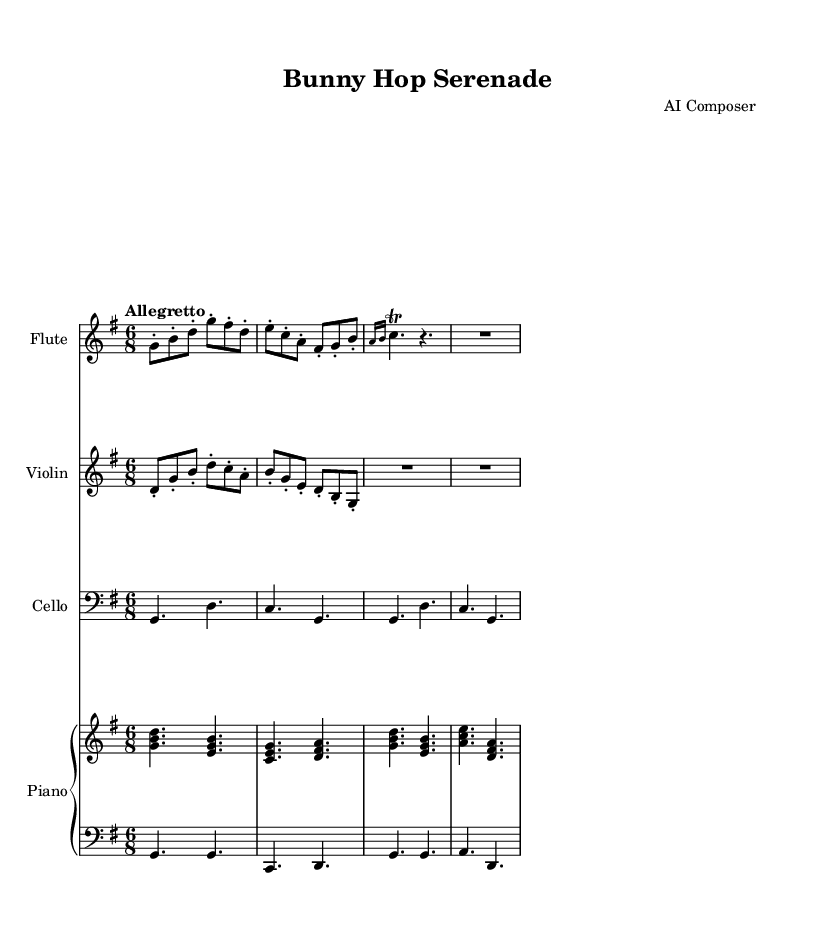What is the key signature of this music? To determine the key signature, we look for the sharps or flats indicated at the beginning of the staff. In this piece, there are no accidentals shown, which indicates that it is in a major key with no sharps or flats. The key signature is G major, known for having one sharp (F#), but since it's not shown here, we take note that it is primarily featuring the natural notes.
Answer: G major What is the time signature of this music? The time signature is found at the beginning of the piece. It indicates how many beats are in each measure and what note value gets the beat. Here, we see that the time signature is 6/8, meaning there are six beats per measure, and the eighth note gets the beat.
Answer: 6/8 What is the tempo marking of this piece? The tempo marking is often found at the beginning of the score, near the clef. In this case, the markings state "Allegretto," which signifies a moderately fast tempo.
Answer: Allegretto How many measures are in the flute part? To determine the number of measures, we need to count the individual sections marked by bar lines. In the flute part, there are 5 measures visible from the notation presented.
Answer: 5 What instruments are included in this chamber music? The instruments are shown at the beginning of each staff with their respective labels. The score includes Flute, Violin, Cello, and Piano. Thus, there are four instruments total in this piece.
Answer: Flute, Violin, Cello, Piano Which section of the music shows a trill? The trill is a decorative note that is indicated by a specific marking. In this sheet music, the flute part shows a trill marked on the note "c4." This is understood as a rapid alternation between notes.
Answer: Flute part What rhythmic pattern is predominantly used in the cello part? To find the rhythmic pattern, we can analyze the note values in the cello part. The cello section uses dotted half notes which provide a specific rhythmic feel. The use of these notes creates a steady and smooth rhythm throughout that contrasts with the bounciness of the other instruments.
Answer: Dotted half notes 